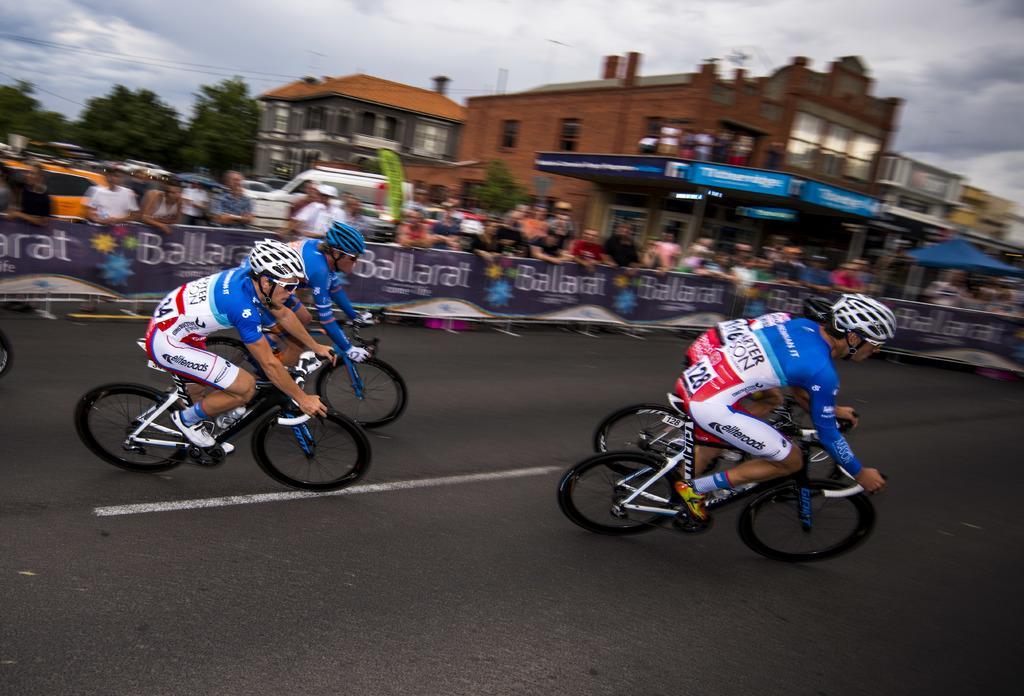Can you describe this image briefly? In the foreground of this image, there are four men riding bicycles on the road. Behind them, there are people standing behind a banner railing. In the background, there are buildings, trees and the sky. 